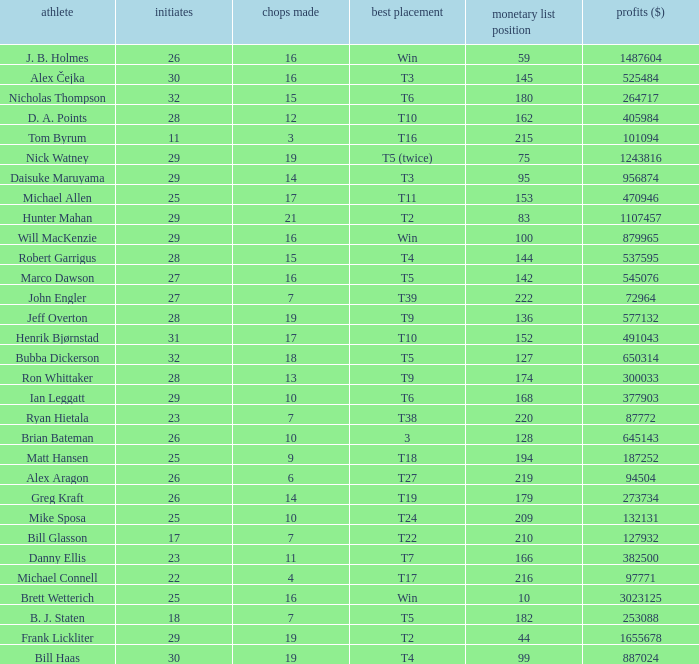What is the minimum number of cuts made for Hunter Mahan? 21.0. 